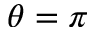Convert formula to latex. <formula><loc_0><loc_0><loc_500><loc_500>\theta = \pi</formula> 